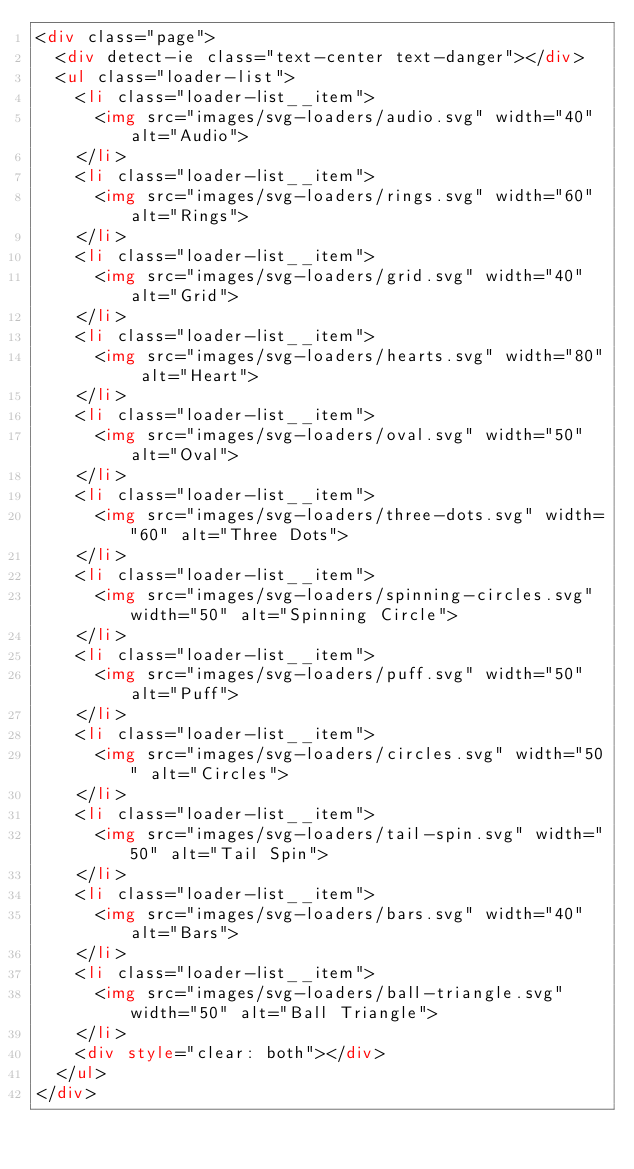Convert code to text. <code><loc_0><loc_0><loc_500><loc_500><_HTML_><div class="page">
  <div detect-ie class="text-center text-danger"></div>
  <ul class="loader-list">
    <li class="loader-list__item">
      <img src="images/svg-loaders/audio.svg" width="40" alt="Audio">
    </li>
    <li class="loader-list__item">
      <img src="images/svg-loaders/rings.svg" width="60" alt="Rings">
    </li>
    <li class="loader-list__item">
      <img src="images/svg-loaders/grid.svg" width="40" alt="Grid">
    </li>
    <li class="loader-list__item">
      <img src="images/svg-loaders/hearts.svg" width="80" alt="Heart">
    </li>
    <li class="loader-list__item">
      <img src="images/svg-loaders/oval.svg" width="50" alt="Oval">
    </li>
    <li class="loader-list__item">
      <img src="images/svg-loaders/three-dots.svg" width="60" alt="Three Dots">
    </li>
    <li class="loader-list__item">
      <img src="images/svg-loaders/spinning-circles.svg" width="50" alt="Spinning Circle">
    </li>
    <li class="loader-list__item">
      <img src="images/svg-loaders/puff.svg" width="50" alt="Puff">
    </li>
    <li class="loader-list__item">
      <img src="images/svg-loaders/circles.svg" width="50" alt="Circles">
    </li>
    <li class="loader-list__item">
      <img src="images/svg-loaders/tail-spin.svg" width="50" alt="Tail Spin">
    </li>
    <li class="loader-list__item">
      <img src="images/svg-loaders/bars.svg" width="40" alt="Bars">
    </li>
    <li class="loader-list__item">
      <img src="images/svg-loaders/ball-triangle.svg" width="50" alt="Ball Triangle">
    </li>
    <div style="clear: both"></div>
  </ul>
</div>
</code> 